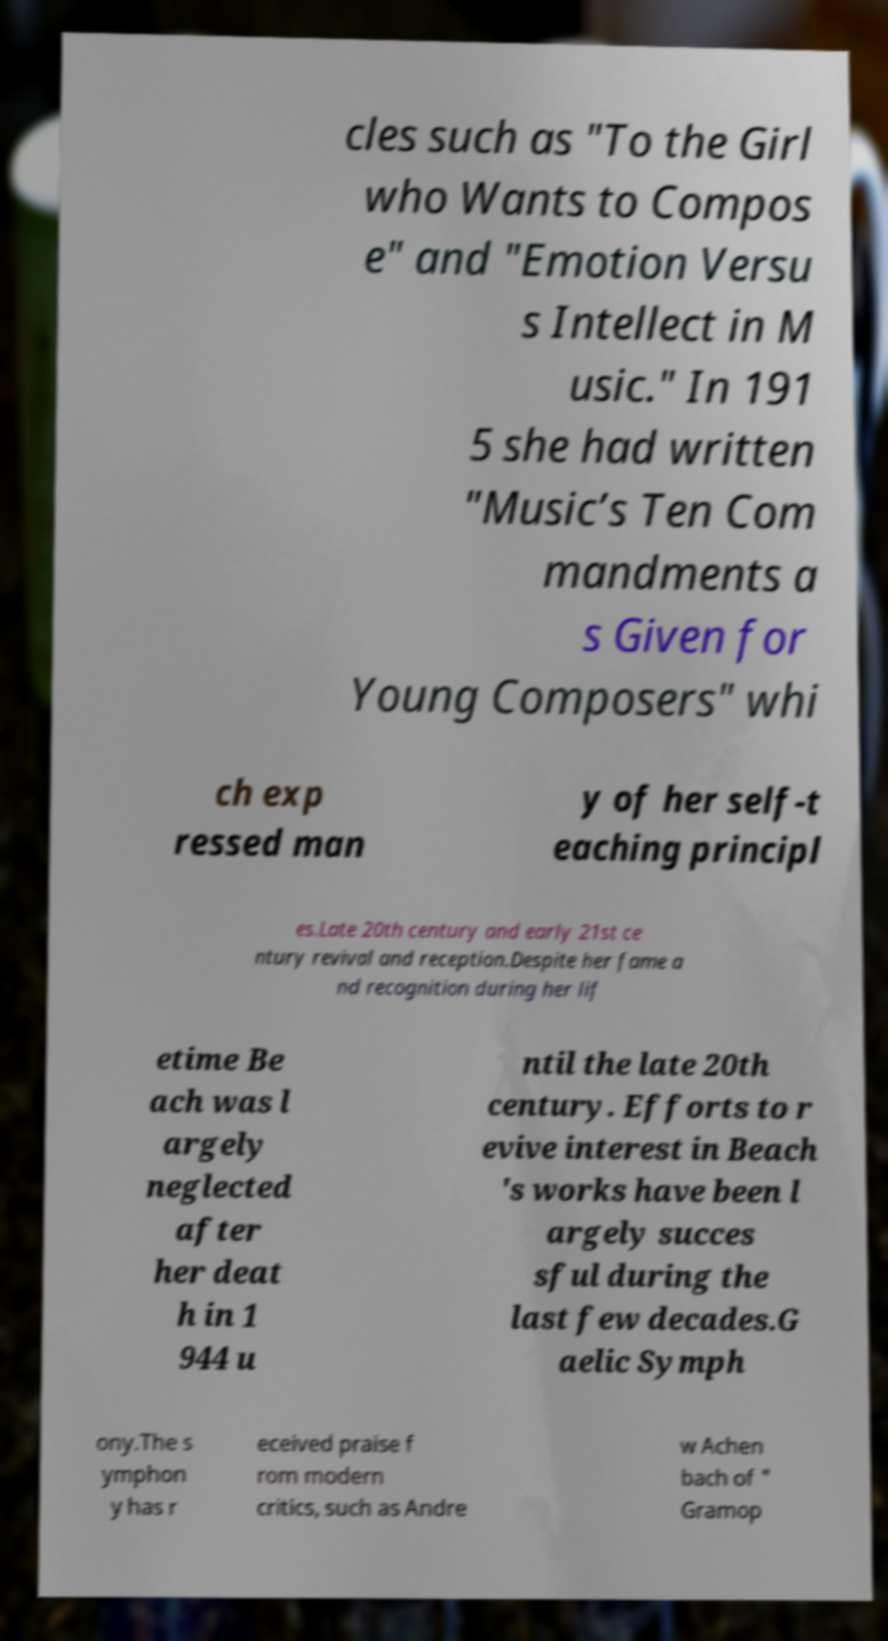Please read and relay the text visible in this image. What does it say? cles such as "To the Girl who Wants to Compos e" and "Emotion Versu s Intellect in M usic." In 191 5 she had written "Music’s Ten Com mandments a s Given for Young Composers" whi ch exp ressed man y of her self-t eaching principl es.Late 20th century and early 21st ce ntury revival and reception.Despite her fame a nd recognition during her lif etime Be ach was l argely neglected after her deat h in 1 944 u ntil the late 20th century. Efforts to r evive interest in Beach 's works have been l argely succes sful during the last few decades.G aelic Symph ony.The s ymphon y has r eceived praise f rom modern critics, such as Andre w Achen bach of " Gramop 